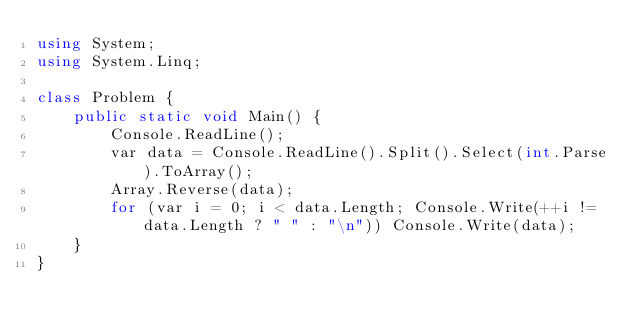Convert code to text. <code><loc_0><loc_0><loc_500><loc_500><_C#_>using System;
using System.Linq;

class Problem {
    public static void Main() {
        Console.ReadLine();
        var data = Console.ReadLine().Split().Select(int.Parse).ToArray();
        Array.Reverse(data);
        for (var i = 0; i < data.Length; Console.Write(++i != data.Length ? " " : "\n")) Console.Write(data);
    }
}
</code> 